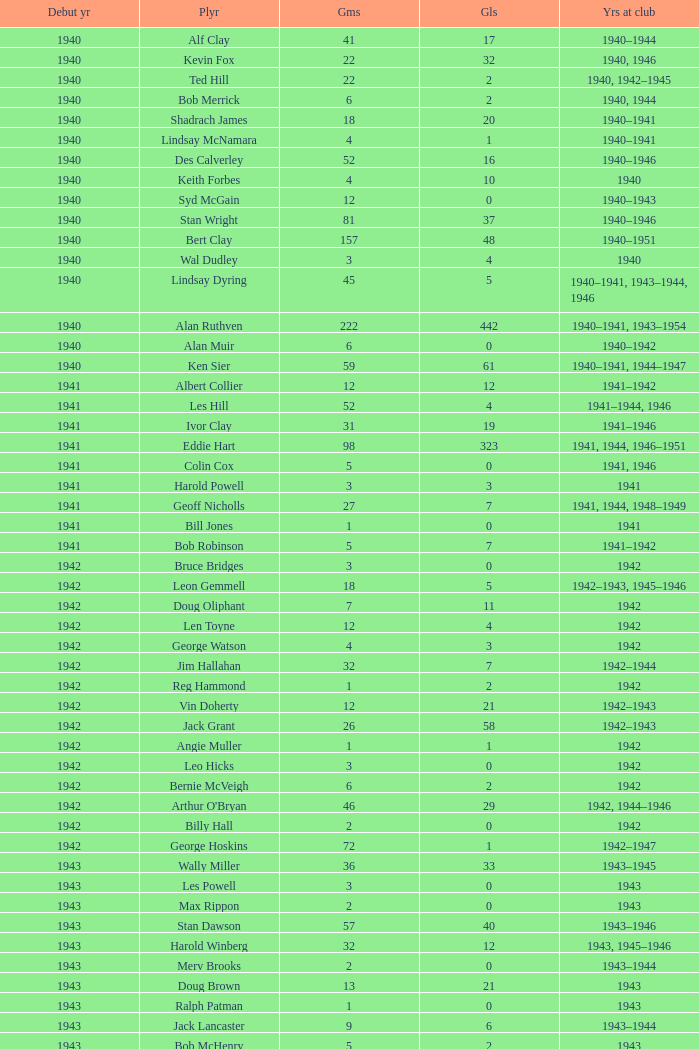Which player debuted before 1943, played for the club in 1942, played less than 12 games, and scored less than 11 goals? Bruce Bridges, George Watson, Reg Hammond, Angie Muller, Leo Hicks, Bernie McVeigh, Billy Hall. 